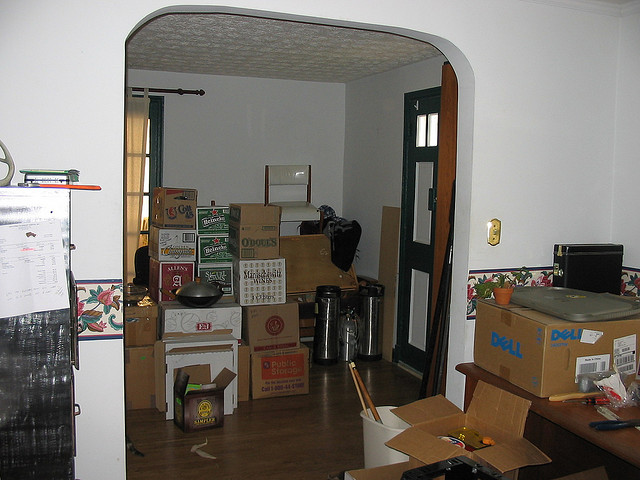Read and extract the text from this image. DELL DELL 